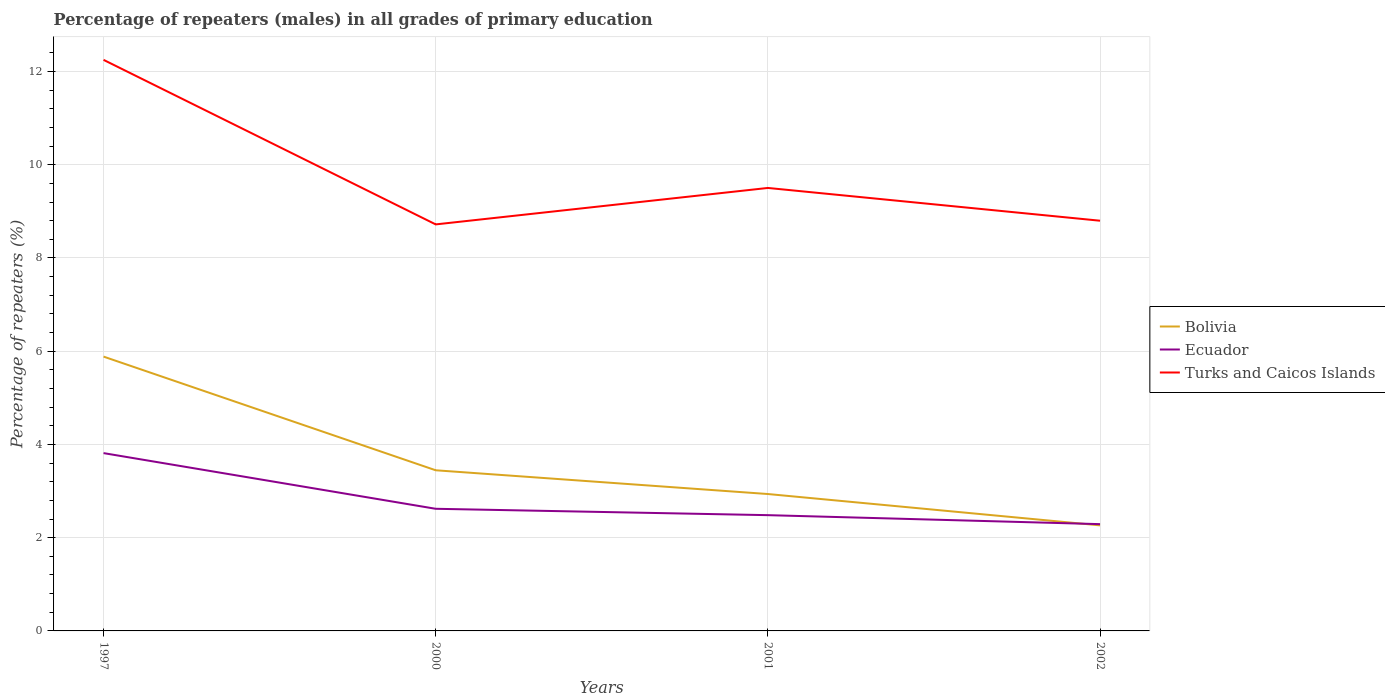How many different coloured lines are there?
Offer a very short reply. 3. Does the line corresponding to Bolivia intersect with the line corresponding to Turks and Caicos Islands?
Your answer should be very brief. No. Across all years, what is the maximum percentage of repeaters (males) in Bolivia?
Offer a very short reply. 2.26. In which year was the percentage of repeaters (males) in Turks and Caicos Islands maximum?
Offer a very short reply. 2000. What is the total percentage of repeaters (males) in Bolivia in the graph?
Offer a very short reply. 0.67. What is the difference between the highest and the second highest percentage of repeaters (males) in Turks and Caicos Islands?
Give a very brief answer. 3.53. What is the difference between the highest and the lowest percentage of repeaters (males) in Ecuador?
Provide a succinct answer. 1. How many years are there in the graph?
Your answer should be compact. 4. What is the difference between two consecutive major ticks on the Y-axis?
Ensure brevity in your answer.  2. Where does the legend appear in the graph?
Ensure brevity in your answer.  Center right. What is the title of the graph?
Provide a succinct answer. Percentage of repeaters (males) in all grades of primary education. What is the label or title of the X-axis?
Make the answer very short. Years. What is the label or title of the Y-axis?
Provide a succinct answer. Percentage of repeaters (%). What is the Percentage of repeaters (%) of Bolivia in 1997?
Give a very brief answer. 5.88. What is the Percentage of repeaters (%) of Ecuador in 1997?
Keep it short and to the point. 3.81. What is the Percentage of repeaters (%) in Turks and Caicos Islands in 1997?
Your answer should be very brief. 12.25. What is the Percentage of repeaters (%) in Bolivia in 2000?
Provide a succinct answer. 3.45. What is the Percentage of repeaters (%) in Ecuador in 2000?
Your response must be concise. 2.62. What is the Percentage of repeaters (%) of Turks and Caicos Islands in 2000?
Make the answer very short. 8.72. What is the Percentage of repeaters (%) of Bolivia in 2001?
Offer a terse response. 2.94. What is the Percentage of repeaters (%) of Ecuador in 2001?
Ensure brevity in your answer.  2.48. What is the Percentage of repeaters (%) in Turks and Caicos Islands in 2001?
Keep it short and to the point. 9.5. What is the Percentage of repeaters (%) of Bolivia in 2002?
Your response must be concise. 2.26. What is the Percentage of repeaters (%) of Ecuador in 2002?
Offer a very short reply. 2.29. What is the Percentage of repeaters (%) of Turks and Caicos Islands in 2002?
Your answer should be compact. 8.8. Across all years, what is the maximum Percentage of repeaters (%) of Bolivia?
Your answer should be compact. 5.88. Across all years, what is the maximum Percentage of repeaters (%) in Ecuador?
Your answer should be compact. 3.81. Across all years, what is the maximum Percentage of repeaters (%) in Turks and Caicos Islands?
Your answer should be very brief. 12.25. Across all years, what is the minimum Percentage of repeaters (%) in Bolivia?
Provide a succinct answer. 2.26. Across all years, what is the minimum Percentage of repeaters (%) of Ecuador?
Your response must be concise. 2.29. Across all years, what is the minimum Percentage of repeaters (%) in Turks and Caicos Islands?
Make the answer very short. 8.72. What is the total Percentage of repeaters (%) in Bolivia in the graph?
Your response must be concise. 14.53. What is the total Percentage of repeaters (%) of Ecuador in the graph?
Give a very brief answer. 11.21. What is the total Percentage of repeaters (%) of Turks and Caicos Islands in the graph?
Your answer should be very brief. 39.27. What is the difference between the Percentage of repeaters (%) of Bolivia in 1997 and that in 2000?
Make the answer very short. 2.44. What is the difference between the Percentage of repeaters (%) in Ecuador in 1997 and that in 2000?
Provide a succinct answer. 1.19. What is the difference between the Percentage of repeaters (%) in Turks and Caicos Islands in 1997 and that in 2000?
Keep it short and to the point. 3.53. What is the difference between the Percentage of repeaters (%) of Bolivia in 1997 and that in 2001?
Offer a very short reply. 2.95. What is the difference between the Percentage of repeaters (%) of Ecuador in 1997 and that in 2001?
Keep it short and to the point. 1.33. What is the difference between the Percentage of repeaters (%) of Turks and Caicos Islands in 1997 and that in 2001?
Your answer should be compact. 2.75. What is the difference between the Percentage of repeaters (%) of Bolivia in 1997 and that in 2002?
Make the answer very short. 3.62. What is the difference between the Percentage of repeaters (%) of Ecuador in 1997 and that in 2002?
Ensure brevity in your answer.  1.52. What is the difference between the Percentage of repeaters (%) of Turks and Caicos Islands in 1997 and that in 2002?
Your answer should be very brief. 3.45. What is the difference between the Percentage of repeaters (%) in Bolivia in 2000 and that in 2001?
Your answer should be compact. 0.51. What is the difference between the Percentage of repeaters (%) of Ecuador in 2000 and that in 2001?
Your answer should be very brief. 0.14. What is the difference between the Percentage of repeaters (%) of Turks and Caicos Islands in 2000 and that in 2001?
Provide a short and direct response. -0.78. What is the difference between the Percentage of repeaters (%) in Bolivia in 2000 and that in 2002?
Keep it short and to the point. 1.18. What is the difference between the Percentage of repeaters (%) of Ecuador in 2000 and that in 2002?
Your response must be concise. 0.33. What is the difference between the Percentage of repeaters (%) of Turks and Caicos Islands in 2000 and that in 2002?
Your answer should be compact. -0.08. What is the difference between the Percentage of repeaters (%) of Bolivia in 2001 and that in 2002?
Offer a terse response. 0.67. What is the difference between the Percentage of repeaters (%) in Ecuador in 2001 and that in 2002?
Provide a succinct answer. 0.19. What is the difference between the Percentage of repeaters (%) in Turks and Caicos Islands in 2001 and that in 2002?
Provide a succinct answer. 0.7. What is the difference between the Percentage of repeaters (%) in Bolivia in 1997 and the Percentage of repeaters (%) in Ecuador in 2000?
Your response must be concise. 3.26. What is the difference between the Percentage of repeaters (%) in Bolivia in 1997 and the Percentage of repeaters (%) in Turks and Caicos Islands in 2000?
Provide a short and direct response. -2.84. What is the difference between the Percentage of repeaters (%) in Ecuador in 1997 and the Percentage of repeaters (%) in Turks and Caicos Islands in 2000?
Your response must be concise. -4.91. What is the difference between the Percentage of repeaters (%) in Bolivia in 1997 and the Percentage of repeaters (%) in Ecuador in 2001?
Your response must be concise. 3.4. What is the difference between the Percentage of repeaters (%) of Bolivia in 1997 and the Percentage of repeaters (%) of Turks and Caicos Islands in 2001?
Your answer should be compact. -3.62. What is the difference between the Percentage of repeaters (%) of Ecuador in 1997 and the Percentage of repeaters (%) of Turks and Caicos Islands in 2001?
Keep it short and to the point. -5.69. What is the difference between the Percentage of repeaters (%) in Bolivia in 1997 and the Percentage of repeaters (%) in Ecuador in 2002?
Your response must be concise. 3.59. What is the difference between the Percentage of repeaters (%) of Bolivia in 1997 and the Percentage of repeaters (%) of Turks and Caicos Islands in 2002?
Your response must be concise. -2.91. What is the difference between the Percentage of repeaters (%) of Ecuador in 1997 and the Percentage of repeaters (%) of Turks and Caicos Islands in 2002?
Provide a short and direct response. -4.99. What is the difference between the Percentage of repeaters (%) of Bolivia in 2000 and the Percentage of repeaters (%) of Ecuador in 2001?
Provide a succinct answer. 0.96. What is the difference between the Percentage of repeaters (%) in Bolivia in 2000 and the Percentage of repeaters (%) in Turks and Caicos Islands in 2001?
Provide a succinct answer. -6.06. What is the difference between the Percentage of repeaters (%) in Ecuador in 2000 and the Percentage of repeaters (%) in Turks and Caicos Islands in 2001?
Offer a very short reply. -6.88. What is the difference between the Percentage of repeaters (%) of Bolivia in 2000 and the Percentage of repeaters (%) of Ecuador in 2002?
Your answer should be compact. 1.16. What is the difference between the Percentage of repeaters (%) of Bolivia in 2000 and the Percentage of repeaters (%) of Turks and Caicos Islands in 2002?
Your answer should be very brief. -5.35. What is the difference between the Percentage of repeaters (%) of Ecuador in 2000 and the Percentage of repeaters (%) of Turks and Caicos Islands in 2002?
Make the answer very short. -6.18. What is the difference between the Percentage of repeaters (%) of Bolivia in 2001 and the Percentage of repeaters (%) of Ecuador in 2002?
Your answer should be very brief. 0.65. What is the difference between the Percentage of repeaters (%) of Bolivia in 2001 and the Percentage of repeaters (%) of Turks and Caicos Islands in 2002?
Give a very brief answer. -5.86. What is the difference between the Percentage of repeaters (%) in Ecuador in 2001 and the Percentage of repeaters (%) in Turks and Caicos Islands in 2002?
Provide a succinct answer. -6.32. What is the average Percentage of repeaters (%) in Bolivia per year?
Provide a succinct answer. 3.63. What is the average Percentage of repeaters (%) in Ecuador per year?
Offer a very short reply. 2.8. What is the average Percentage of repeaters (%) in Turks and Caicos Islands per year?
Ensure brevity in your answer.  9.82. In the year 1997, what is the difference between the Percentage of repeaters (%) of Bolivia and Percentage of repeaters (%) of Ecuador?
Keep it short and to the point. 2.07. In the year 1997, what is the difference between the Percentage of repeaters (%) of Bolivia and Percentage of repeaters (%) of Turks and Caicos Islands?
Your answer should be compact. -6.37. In the year 1997, what is the difference between the Percentage of repeaters (%) of Ecuador and Percentage of repeaters (%) of Turks and Caicos Islands?
Keep it short and to the point. -8.44. In the year 2000, what is the difference between the Percentage of repeaters (%) in Bolivia and Percentage of repeaters (%) in Ecuador?
Your answer should be compact. 0.83. In the year 2000, what is the difference between the Percentage of repeaters (%) of Bolivia and Percentage of repeaters (%) of Turks and Caicos Islands?
Ensure brevity in your answer.  -5.27. In the year 2000, what is the difference between the Percentage of repeaters (%) in Ecuador and Percentage of repeaters (%) in Turks and Caicos Islands?
Give a very brief answer. -6.1. In the year 2001, what is the difference between the Percentage of repeaters (%) in Bolivia and Percentage of repeaters (%) in Ecuador?
Ensure brevity in your answer.  0.45. In the year 2001, what is the difference between the Percentage of repeaters (%) in Bolivia and Percentage of repeaters (%) in Turks and Caicos Islands?
Your answer should be very brief. -6.57. In the year 2001, what is the difference between the Percentage of repeaters (%) of Ecuador and Percentage of repeaters (%) of Turks and Caicos Islands?
Your answer should be compact. -7.02. In the year 2002, what is the difference between the Percentage of repeaters (%) in Bolivia and Percentage of repeaters (%) in Ecuador?
Offer a very short reply. -0.03. In the year 2002, what is the difference between the Percentage of repeaters (%) of Bolivia and Percentage of repeaters (%) of Turks and Caicos Islands?
Provide a succinct answer. -6.54. In the year 2002, what is the difference between the Percentage of repeaters (%) in Ecuador and Percentage of repeaters (%) in Turks and Caicos Islands?
Provide a short and direct response. -6.51. What is the ratio of the Percentage of repeaters (%) of Bolivia in 1997 to that in 2000?
Give a very brief answer. 1.71. What is the ratio of the Percentage of repeaters (%) in Ecuador in 1997 to that in 2000?
Offer a terse response. 1.46. What is the ratio of the Percentage of repeaters (%) in Turks and Caicos Islands in 1997 to that in 2000?
Give a very brief answer. 1.4. What is the ratio of the Percentage of repeaters (%) of Bolivia in 1997 to that in 2001?
Provide a short and direct response. 2. What is the ratio of the Percentage of repeaters (%) in Ecuador in 1997 to that in 2001?
Provide a succinct answer. 1.54. What is the ratio of the Percentage of repeaters (%) in Turks and Caicos Islands in 1997 to that in 2001?
Ensure brevity in your answer.  1.29. What is the ratio of the Percentage of repeaters (%) of Bolivia in 1997 to that in 2002?
Your response must be concise. 2.6. What is the ratio of the Percentage of repeaters (%) of Ecuador in 1997 to that in 2002?
Keep it short and to the point. 1.67. What is the ratio of the Percentage of repeaters (%) in Turks and Caicos Islands in 1997 to that in 2002?
Your answer should be compact. 1.39. What is the ratio of the Percentage of repeaters (%) in Bolivia in 2000 to that in 2001?
Offer a very short reply. 1.17. What is the ratio of the Percentage of repeaters (%) of Ecuador in 2000 to that in 2001?
Your response must be concise. 1.06. What is the ratio of the Percentage of repeaters (%) of Turks and Caicos Islands in 2000 to that in 2001?
Provide a succinct answer. 0.92. What is the ratio of the Percentage of repeaters (%) of Bolivia in 2000 to that in 2002?
Ensure brevity in your answer.  1.52. What is the ratio of the Percentage of repeaters (%) of Ecuador in 2000 to that in 2002?
Your answer should be compact. 1.14. What is the ratio of the Percentage of repeaters (%) in Turks and Caicos Islands in 2000 to that in 2002?
Keep it short and to the point. 0.99. What is the ratio of the Percentage of repeaters (%) in Bolivia in 2001 to that in 2002?
Your answer should be very brief. 1.3. What is the ratio of the Percentage of repeaters (%) of Ecuador in 2001 to that in 2002?
Make the answer very short. 1.08. What is the ratio of the Percentage of repeaters (%) in Turks and Caicos Islands in 2001 to that in 2002?
Your answer should be very brief. 1.08. What is the difference between the highest and the second highest Percentage of repeaters (%) in Bolivia?
Ensure brevity in your answer.  2.44. What is the difference between the highest and the second highest Percentage of repeaters (%) of Ecuador?
Offer a very short reply. 1.19. What is the difference between the highest and the second highest Percentage of repeaters (%) in Turks and Caicos Islands?
Your answer should be very brief. 2.75. What is the difference between the highest and the lowest Percentage of repeaters (%) of Bolivia?
Provide a short and direct response. 3.62. What is the difference between the highest and the lowest Percentage of repeaters (%) of Ecuador?
Your response must be concise. 1.52. What is the difference between the highest and the lowest Percentage of repeaters (%) of Turks and Caicos Islands?
Your response must be concise. 3.53. 